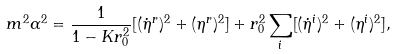<formula> <loc_0><loc_0><loc_500><loc_500>m ^ { 2 } \alpha ^ { 2 } = \frac { 1 } { 1 - K r _ { 0 } ^ { 2 } } [ ( \dot { \eta } ^ { r } ) ^ { 2 } + ( \eta ^ { r } ) ^ { 2 } ] + r _ { 0 } ^ { 2 } \sum _ { i } [ ( \dot { \eta } ^ { i } ) ^ { 2 } + ( \eta ^ { i } ) ^ { 2 } ] ,</formula> 